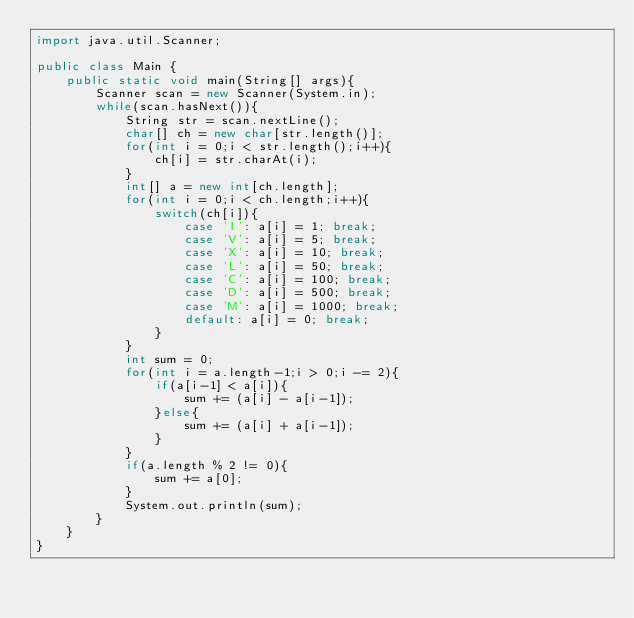Convert code to text. <code><loc_0><loc_0><loc_500><loc_500><_Java_>import java.util.Scanner;

public class Main {
	public static void main(String[] args){
		Scanner scan = new Scanner(System.in);
		while(scan.hasNext()){
			String str = scan.nextLine();
			char[] ch = new char[str.length()];
			for(int i = 0;i < str.length();i++){
				ch[i] = str.charAt(i);
			}
			int[] a = new int[ch.length];
			for(int i = 0;i < ch.length;i++){
				switch(ch[i]){
					case 'I': a[i] = 1;	break;
					case 'V': a[i] = 5; break;
					case 'X': a[i] = 10; break;
					case 'L': a[i] = 50; break;
					case 'C': a[i] = 100; break;
					case 'D': a[i] = 500; break;
					case 'M': a[i] = 1000; break;
					default: a[i] = 0; break;
				}
			}
			int sum = 0;
			for(int i = a.length-1;i > 0;i -= 2){
				if(a[i-1] < a[i]){
					sum += (a[i] - a[i-1]);
				}else{
					sum += (a[i] + a[i-1]);
				}
			}
			if(a.length % 2 != 0){
				sum += a[0];
			}
			System.out.println(sum);
		}
	}
}</code> 